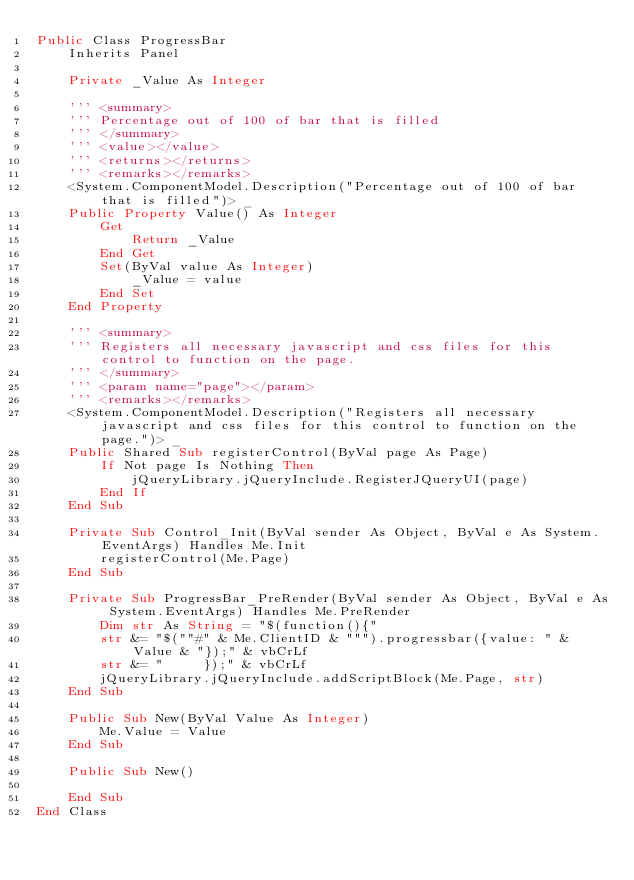Convert code to text. <code><loc_0><loc_0><loc_500><loc_500><_VisualBasic_>Public Class ProgressBar
    Inherits Panel

    Private _Value As Integer

    ''' <summary>
    ''' Percentage out of 100 of bar that is filled
    ''' </summary>
    ''' <value></value>
    ''' <returns></returns>
    ''' <remarks></remarks>
    <System.ComponentModel.Description("Percentage out of 100 of bar that is filled")> _
    Public Property Value() As Integer
        Get
            Return _Value
        End Get
        Set(ByVal value As Integer)
            _Value = value
        End Set
    End Property

    ''' <summary>
    ''' Registers all necessary javascript and css files for this control to function on the page.
    ''' </summary>
    ''' <param name="page"></param>
    ''' <remarks></remarks>
    <System.ComponentModel.Description("Registers all necessary javascript and css files for this control to function on the page.")> _
    Public Shared Sub registerControl(ByVal page As Page)
        If Not page Is Nothing Then
            jQueryLibrary.jQueryInclude.RegisterJQueryUI(page)
        End If
    End Sub

    Private Sub Control_Init(ByVal sender As Object, ByVal e As System.EventArgs) Handles Me.Init
        registerControl(Me.Page)
    End Sub

    Private Sub ProgressBar_PreRender(ByVal sender As Object, ByVal e As System.EventArgs) Handles Me.PreRender
        Dim str As String = "$(function(){"
        str &= "$(""#" & Me.ClientID & """).progressbar({value: " & Value & "});" & vbCrLf
        str &= "     });" & vbCrLf
        jQueryLibrary.jQueryInclude.addScriptBlock(Me.Page, str)
    End Sub

    Public Sub New(ByVal Value As Integer)
        Me.Value = Value
    End Sub

    Public Sub New()

    End Sub
End Class
</code> 